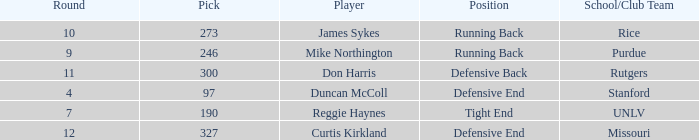What is the total number of rounds that had draft pick 97, duncan mccoll? 0.0. 